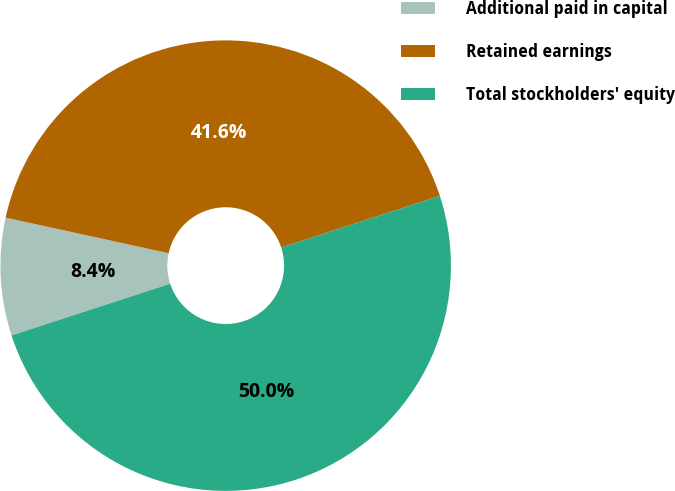<chart> <loc_0><loc_0><loc_500><loc_500><pie_chart><fcel>Additional paid in capital<fcel>Retained earnings<fcel>Total stockholders' equity<nl><fcel>8.43%<fcel>41.57%<fcel>50.0%<nl></chart> 